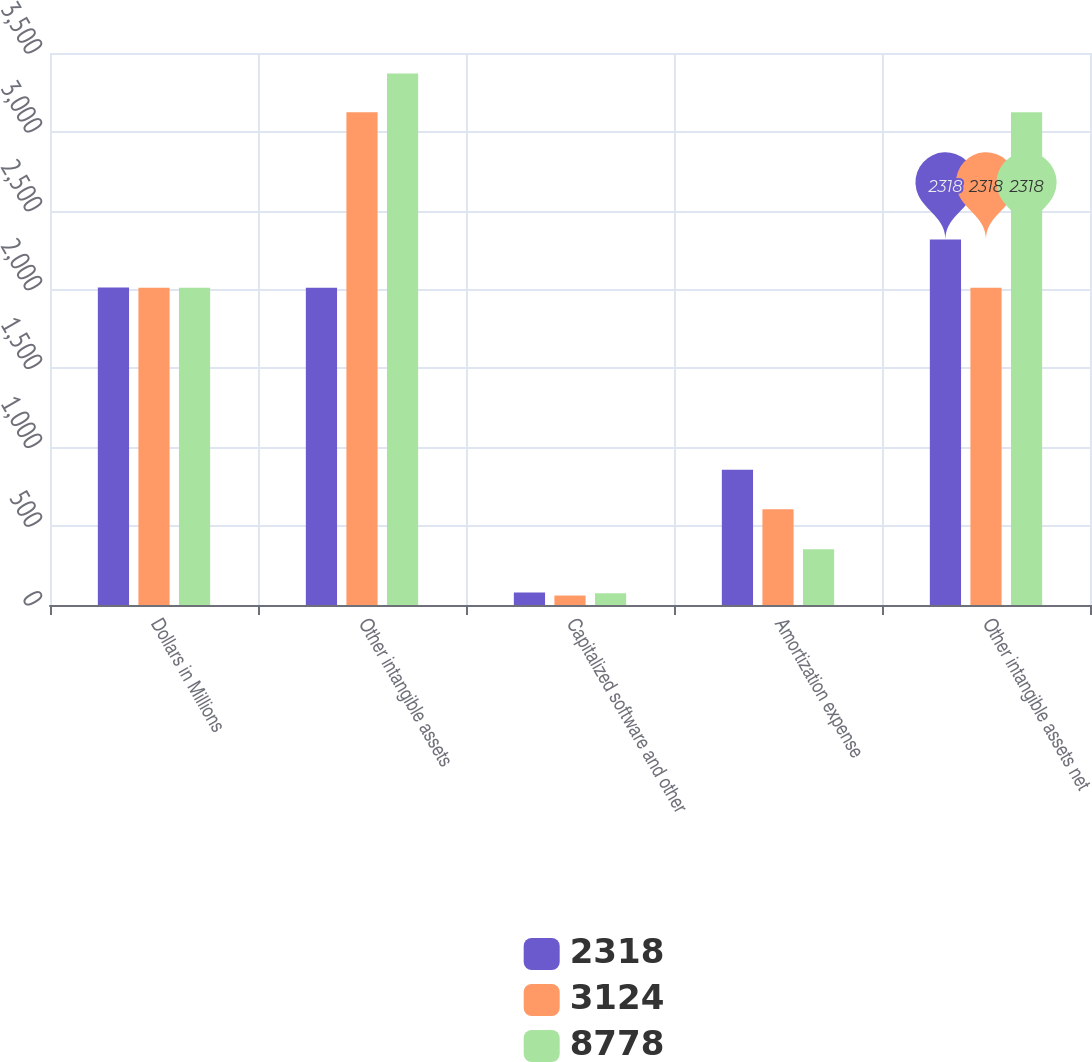<chart> <loc_0><loc_0><loc_500><loc_500><stacked_bar_chart><ecel><fcel>Dollars in Millions<fcel>Other intangible assets<fcel>Capitalized software and other<fcel>Amortization expense<fcel>Other intangible assets net<nl><fcel>2318<fcel>2013<fcel>2011<fcel>80<fcel>858<fcel>2318<nl><fcel>3124<fcel>2012<fcel>3124<fcel>60<fcel>607<fcel>2011<nl><fcel>8778<fcel>2011<fcel>3370<fcel>75<fcel>353<fcel>3124<nl></chart> 